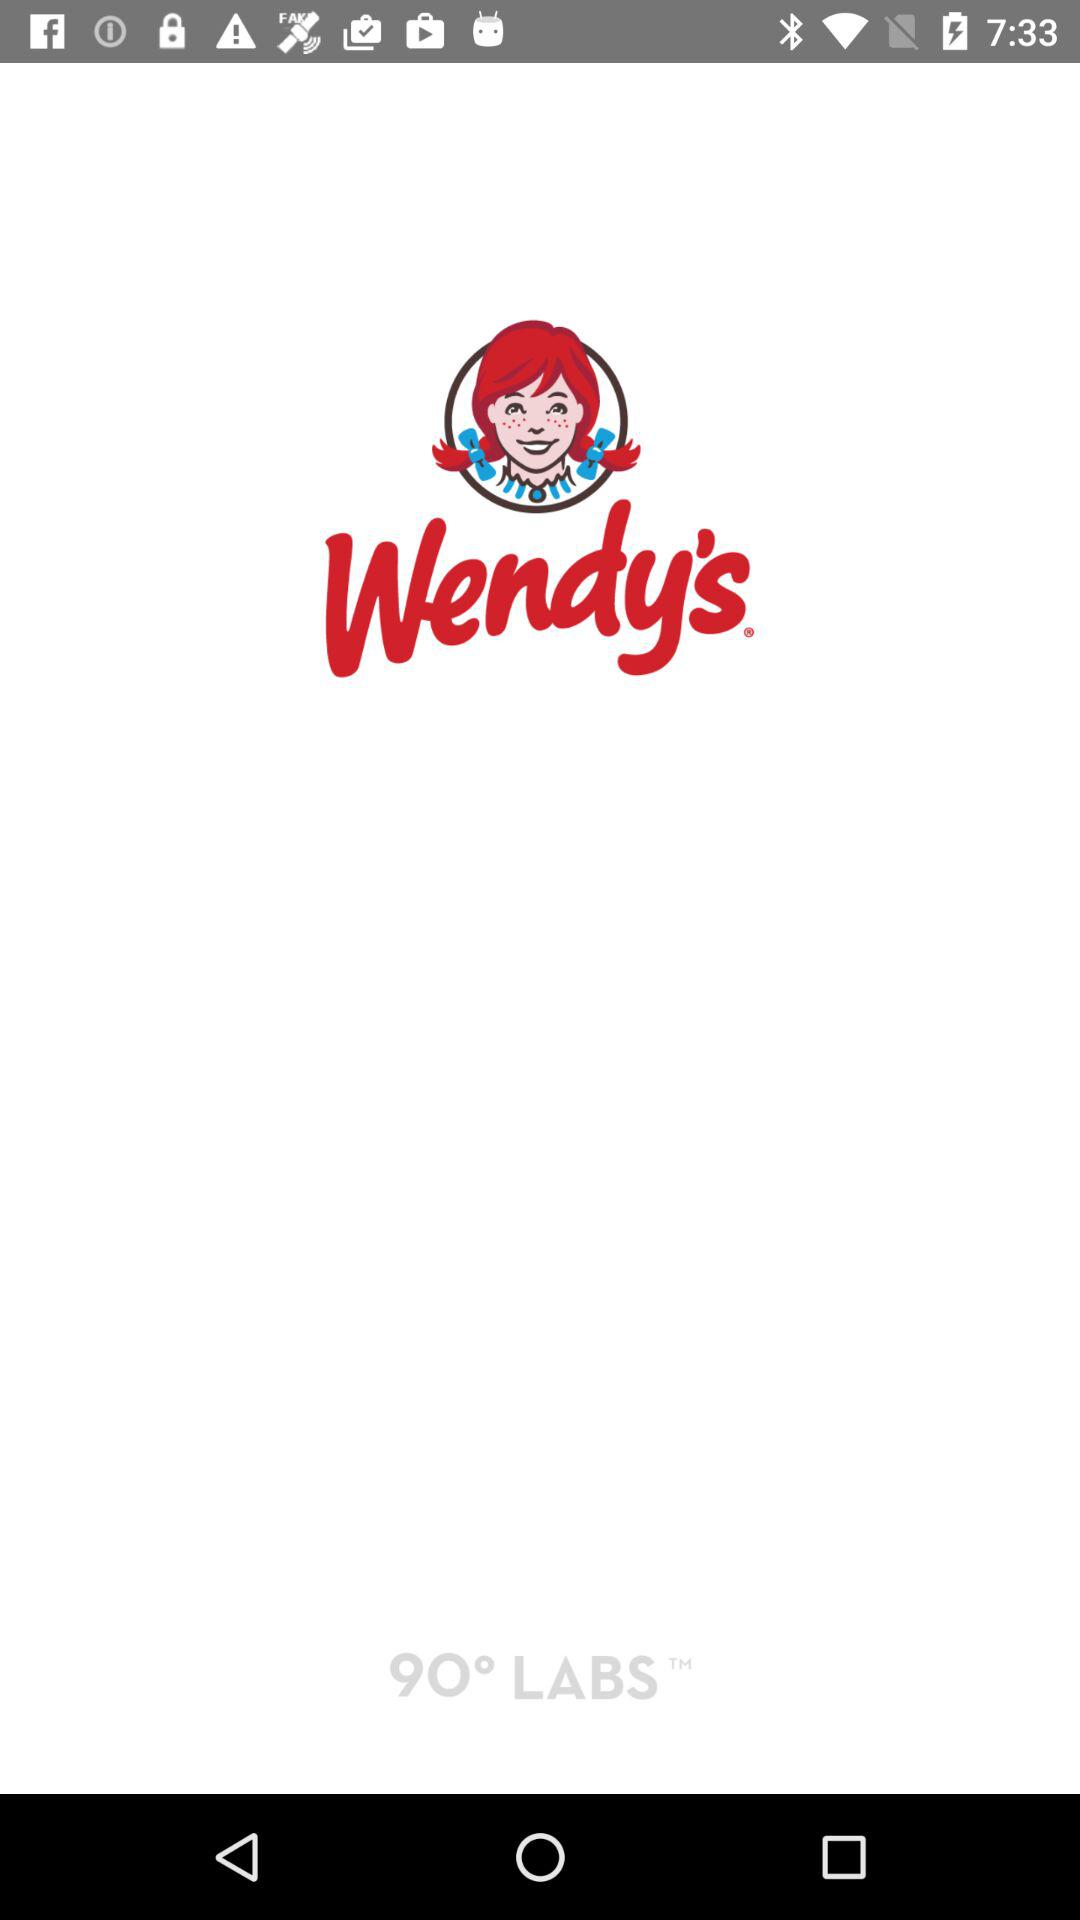What is the name of the application? The name of the application is "Wendy's". 